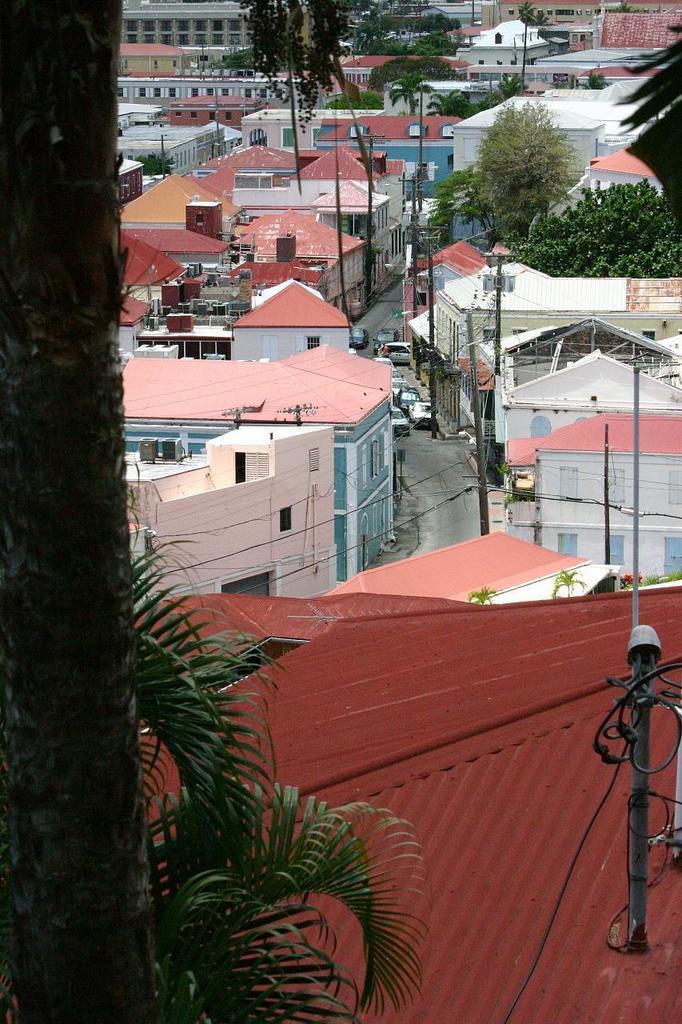Please provide a concise description of this image. There are many houses in the image. There are many trees in the image. There are few cars are parked on the road. 